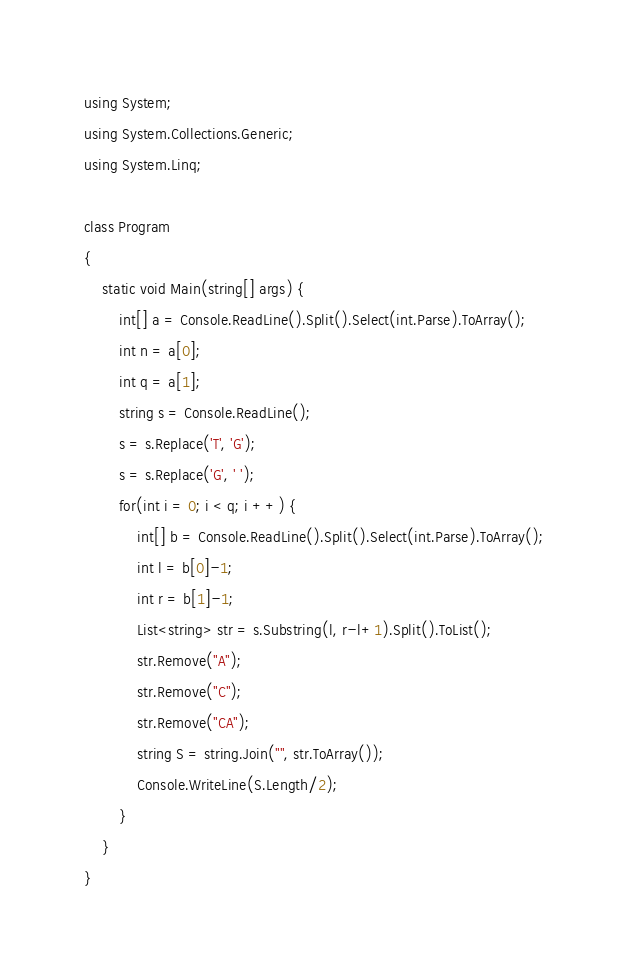<code> <loc_0><loc_0><loc_500><loc_500><_C#_>using System;
using System.Collections.Generic;
using System.Linq;

class Program
{
    static void Main(string[] args) {
        int[] a = Console.ReadLine().Split().Select(int.Parse).ToArray();
        int n = a[0];
        int q = a[1];
        string s = Console.ReadLine();
        s = s.Replace('T', 'G');
        s = s.Replace('G', ' ');
        for(int i = 0; i < q; i ++) {
            int[] b = Console.ReadLine().Split().Select(int.Parse).ToArray();
            int l = b[0]-1;
            int r = b[1]-1;
            List<string> str = s.Substring(l, r-l+1).Split().ToList();
            str.Remove("A");
            str.Remove("C");
            str.Remove("CA");
            string S = string.Join("", str.ToArray());
            Console.WriteLine(S.Length/2);
        }
    }
}</code> 